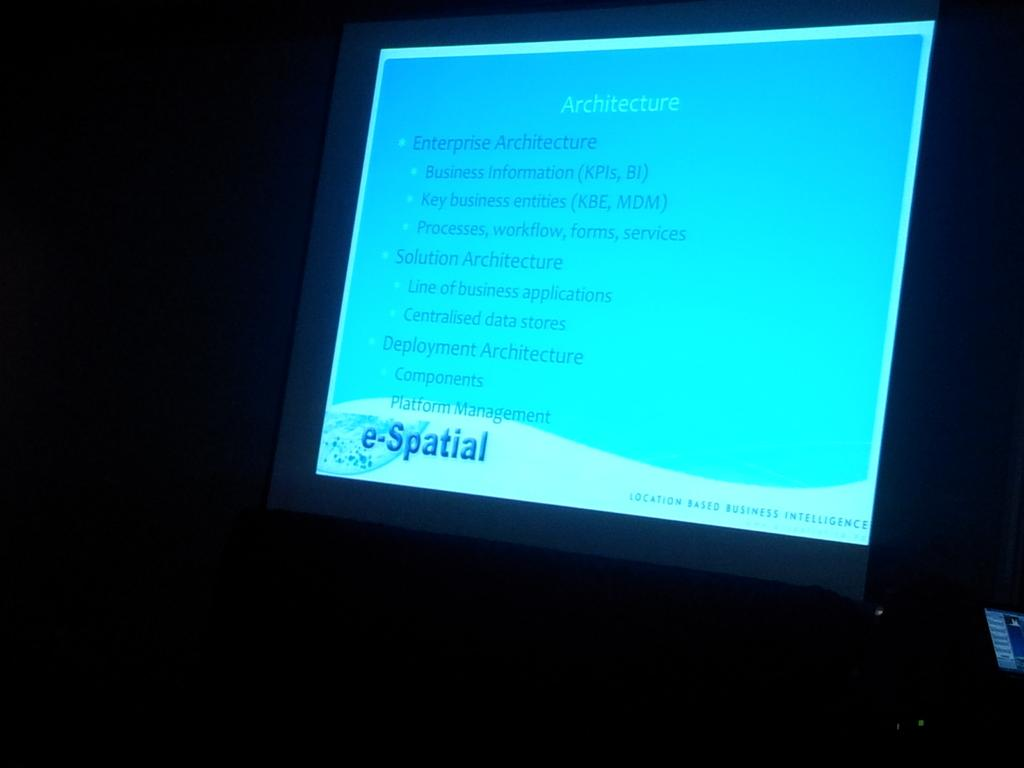Provide a one-sentence caption for the provided image. A power point presentation about Architecture with bullet points. 